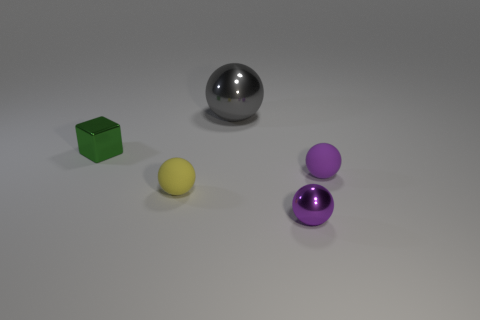Add 4 shiny objects. How many objects exist? 9 Subtract all cubes. How many objects are left? 4 Subtract 0 green cylinders. How many objects are left? 5 Subtract all small purple rubber balls. Subtract all small yellow cylinders. How many objects are left? 4 Add 5 purple matte spheres. How many purple matte spheres are left? 6 Add 5 small blocks. How many small blocks exist? 6 